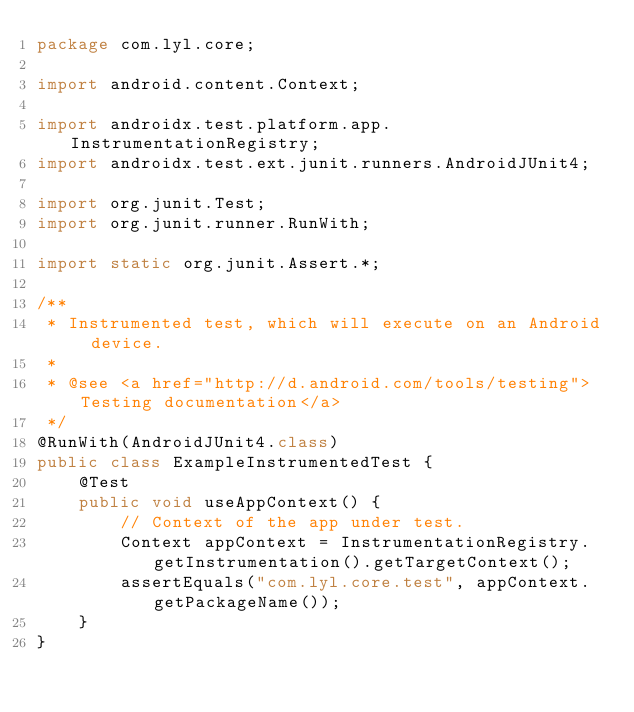<code> <loc_0><loc_0><loc_500><loc_500><_Java_>package com.lyl.core;

import android.content.Context;

import androidx.test.platform.app.InstrumentationRegistry;
import androidx.test.ext.junit.runners.AndroidJUnit4;

import org.junit.Test;
import org.junit.runner.RunWith;

import static org.junit.Assert.*;

/**
 * Instrumented test, which will execute on an Android device.
 *
 * @see <a href="http://d.android.com/tools/testing">Testing documentation</a>
 */
@RunWith(AndroidJUnit4.class)
public class ExampleInstrumentedTest {
    @Test
    public void useAppContext() {
        // Context of the app under test.
        Context appContext = InstrumentationRegistry.getInstrumentation().getTargetContext();
        assertEquals("com.lyl.core.test", appContext.getPackageName());
    }
}</code> 